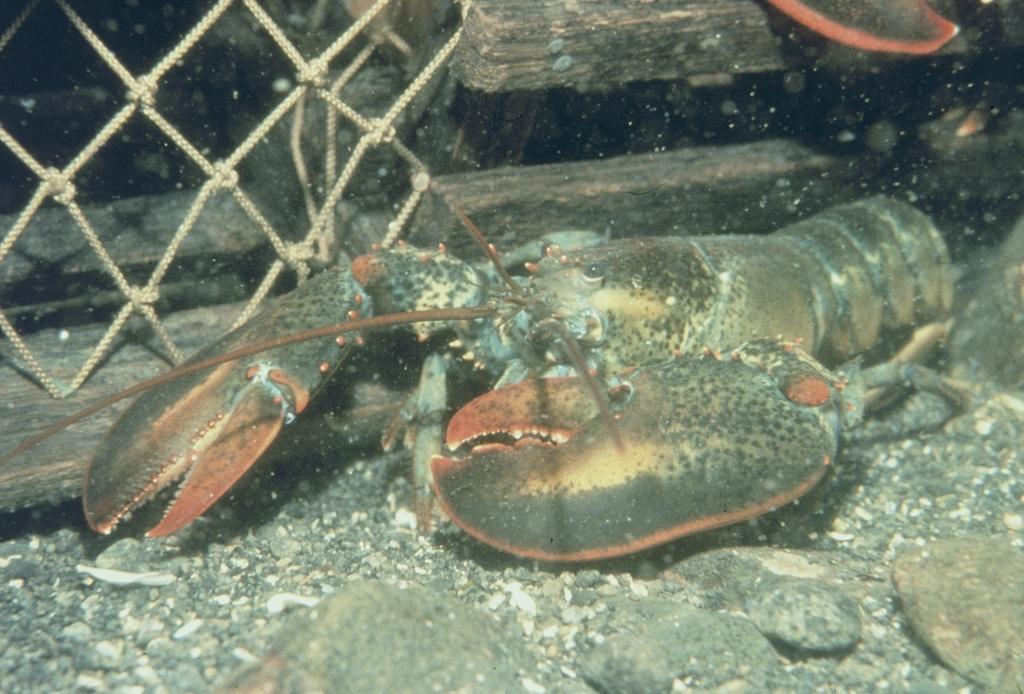What type of sea creature is in the image? There is a lobster in the image. Where is the lobster located? The lobster is in the water. What can be seen at the bottom of the image? There are stones at the bottom of the image. What objects are visible in the background of the image? There are wooden objects and a net in the background of the image. What type of belief is depicted in the image? There is no belief depicted in the image; it features a lobster in the water with stones at the bottom and wooden objects and a net in the background. How many snails can be seen in the image? There are no snails present in the image. 